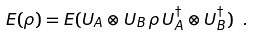<formula> <loc_0><loc_0><loc_500><loc_500>E ( \rho ) = E ( U _ { A } \otimes U _ { B } \, \rho \, U _ { A } ^ { \dagger } \otimes U _ { B } ^ { \dagger } ) \ .</formula> 